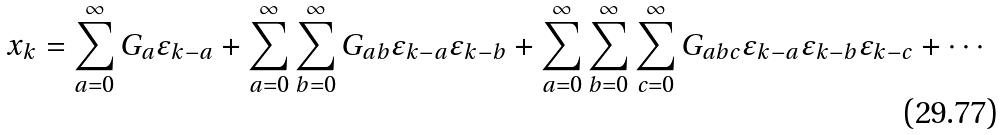<formula> <loc_0><loc_0><loc_500><loc_500>x _ { k } = \sum _ { a = 0 } ^ { \infty } G _ { a } \varepsilon _ { k - a } + \sum _ { a = 0 } ^ { \infty } \sum _ { b = 0 } ^ { \infty } G _ { a b } \varepsilon _ { k - a } \varepsilon _ { k - b } + \sum _ { a = 0 } ^ { \infty } \sum _ { b = 0 } ^ { \infty } \sum _ { c = 0 } ^ { \infty } G _ { a b c } \varepsilon _ { k - a } \varepsilon _ { k - b } \varepsilon _ { k - c } + \cdots</formula> 